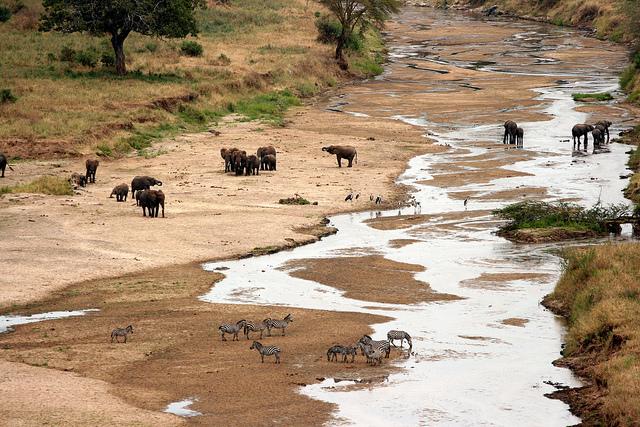Are the animals in the water?
Be succinct. Yes. What are the animals doing?
Be succinct. Drinking. Where might this scene take place?
Give a very brief answer. Africa. How many animals are in the photo?
Keep it brief. 15. What is white?
Short answer required. Water. 